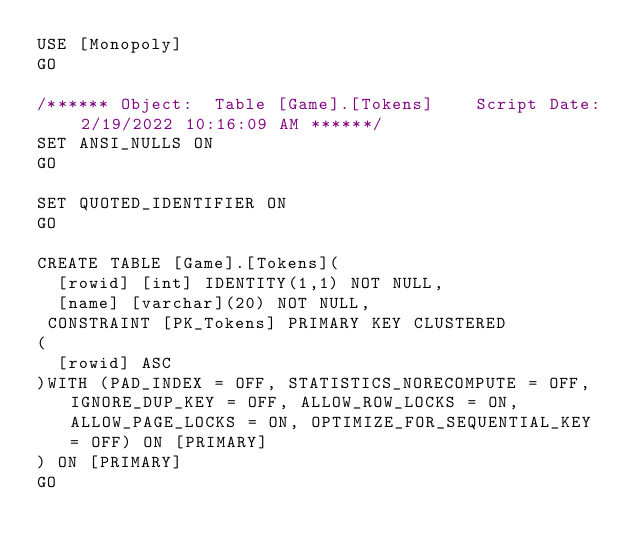Convert code to text. <code><loc_0><loc_0><loc_500><loc_500><_SQL_>USE [Monopoly]
GO

/****** Object:  Table [Game].[Tokens]    Script Date: 2/19/2022 10:16:09 AM ******/
SET ANSI_NULLS ON
GO

SET QUOTED_IDENTIFIER ON
GO

CREATE TABLE [Game].[Tokens](
	[rowid] [int] IDENTITY(1,1) NOT NULL,
	[name] [varchar](20) NOT NULL,
 CONSTRAINT [PK_Tokens] PRIMARY KEY CLUSTERED 
(
	[rowid] ASC
)WITH (PAD_INDEX = OFF, STATISTICS_NORECOMPUTE = OFF, IGNORE_DUP_KEY = OFF, ALLOW_ROW_LOCKS = ON, ALLOW_PAGE_LOCKS = ON, OPTIMIZE_FOR_SEQUENTIAL_KEY = OFF) ON [PRIMARY]
) ON [PRIMARY]
GO


</code> 